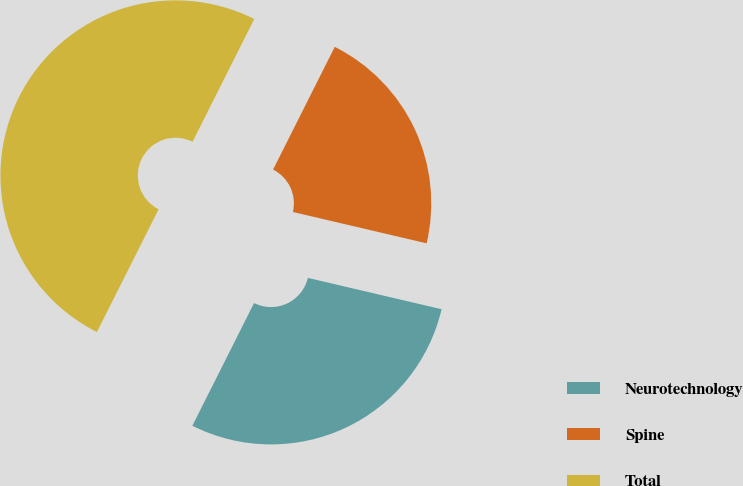Convert chart. <chart><loc_0><loc_0><loc_500><loc_500><pie_chart><fcel>Neurotechnology<fcel>Spine<fcel>Total<nl><fcel>28.75%<fcel>21.25%<fcel>50.0%<nl></chart> 